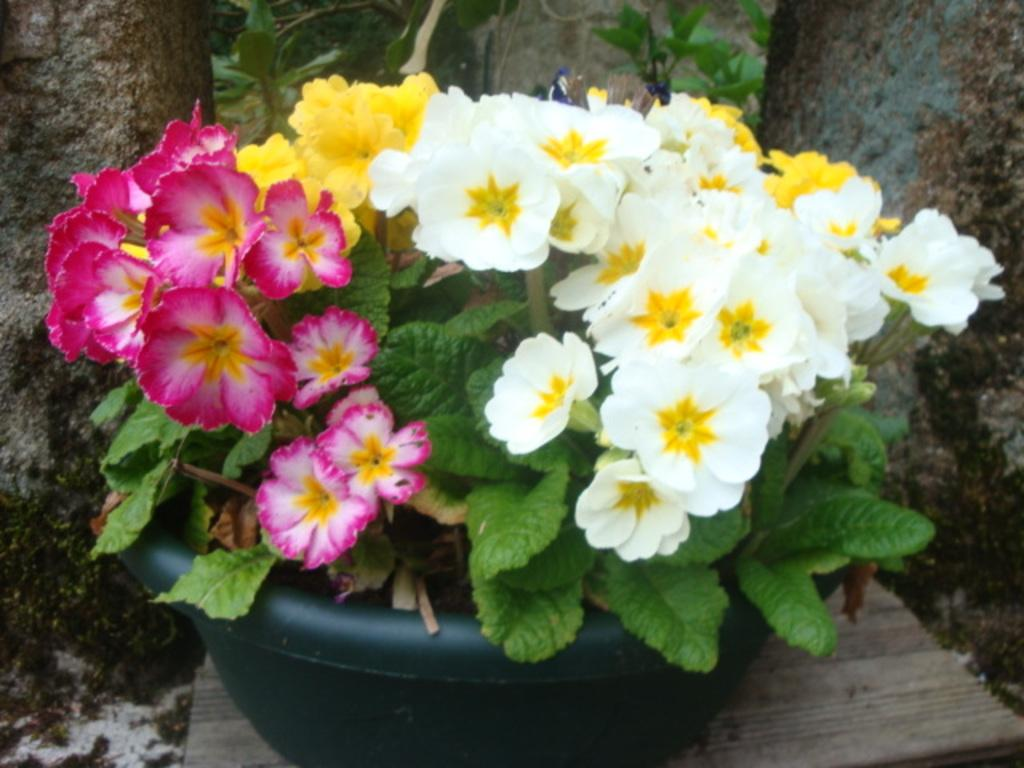What type of plants are visible in the image? There are flowers and green leaves in the image. What is the flowers and leaves contained in? There is a pot in the image that contains the flowers and leaves. What is located at the bottom of the image? There is an object at the bottom of the image, but its description is not provided in the facts. What can be seen in the background of the image? There is a wall and algae visible in the background of the image. What is the condition of the horse in the image? There is no horse present in the image, so its condition cannot be determined. 